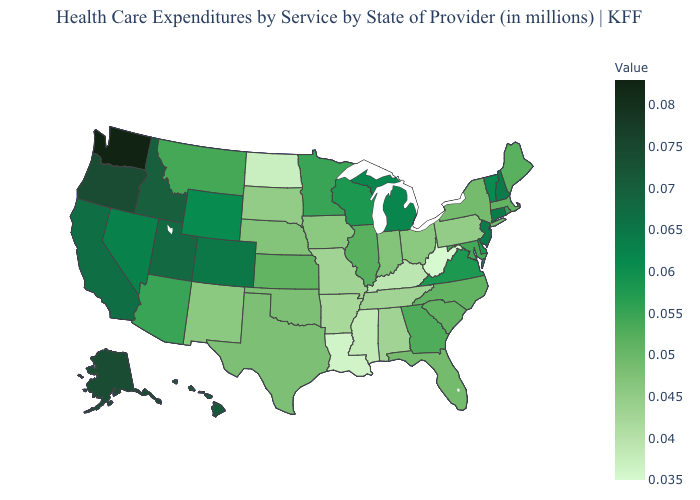Does Maine have a lower value than New Hampshire?
Short answer required. Yes. Among the states that border Minnesota , does Wisconsin have the lowest value?
Give a very brief answer. No. Which states hav the highest value in the South?
Concise answer only. Delaware, Virginia. Among the states that border Louisiana , does Mississippi have the lowest value?
Quick response, please. Yes. 